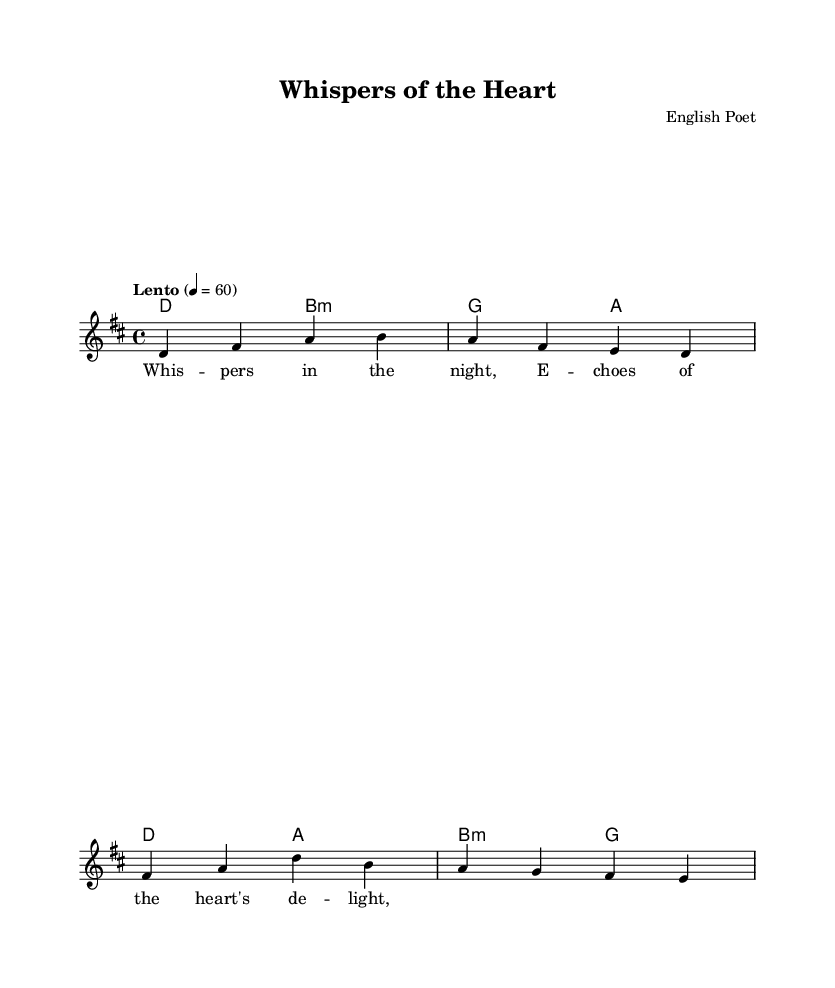What is the key signature of this music? The key signature is D major, which has two sharps: F sharp and C sharp.
Answer: D major What is the time signature of this music? The time signature is 4/4, indicating four beats per measure, with the quarter note receiving one beat.
Answer: 4/4 What is the tempo marking of this piece? The tempo marking is "Lento," which generally means a slow and leisurely pace.
Answer: Lento How many measures are in the melody section? There are four measures in the melody section, as indicated by the four groups of notes separated by vertical bar lines.
Answer: 4 What type of chords are used in the harmonies? The harmonies include major and minor chords, with specific chords like D major, B minor, G major, and A major.
Answer: Major and minor Which lyric communicates emotion in the piece? The lyric "Whispers in the night" evokes a sense of intimacy and vulnerability, capturing deep human emotions.
Answer: Whispers in the night How does the tempo affect the feel of the ballad? The lento tempo contributes to a reflective and poignant atmosphere, allowing the emotional depths of the lyrics to resonate.
Answer: Reflective 